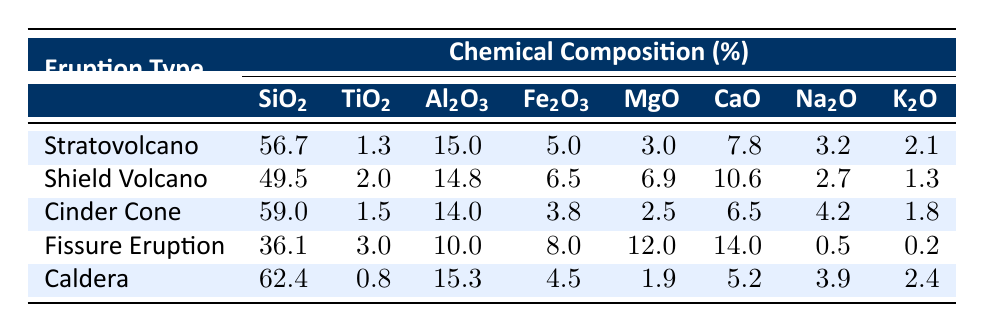What is the SiO2 percentage for the Stratovolcano sample? The table shows that the SiO2 percentage for the Stratovolcano sample (SV001) is listed directly in the corresponding cell under the SiO2 column for that eruption type.
Answer: 56.7 Which eruption type has the highest K2O content? By comparing the K2O values for each eruption type in the table, I can see that the Caldera eruption type (CA005) has the highest K2O content at 2.4.
Answer: Caldera What is the average Fe2O3 content across all eruption types? To find the average Fe2O3 content, I add the Fe2O3 values (5.0 + 6.5 + 3.8 + 8.0 + 4.5 = 27.8) and divide by the number of eruption types (5). The average is 27.8 / 5 = 5.56.
Answer: 5.56 Does the Cinder Cone eruption type have the lowest MgO content? I check the MgO values for all eruption types and find that Cinder Cone (CC003) has a MgO content of 2.5, which is higher than Fissure Eruption (FE004) at 12.0 and lower than both Stratovolcano and Shield Volcano, thus it's false.
Answer: No What is the difference in SiO2 content between the Stratovolcano and Caldera eruption types? The SiO2 content for the Stratovolcano is 56.7 and for the Caldera it is 62.4. To find the difference, I subtract the SiO2 of Stratovolcano from Caldera: 62.4 - 56.7 = 5.7.
Answer: 5.7 Which eruption type has the lowest Na2O content? By examining the Na2O content across the eruption types, I find that the Fissure Eruption sample (FE004) has the lowest Na2O, with a value of 0.5.
Answer: Fissure Eruption What is the total Al2O3 content for Shield Volcano and Caldera? I need to add the Al2O3 values from both Shield Volcano (14.8) and Caldera (15.3). Therefore, the total Al2O3 content is 14.8 + 15.3 = 30.1.
Answer: 30.1 Are the TiO2 levels higher in Cinder Cone than in Stratovolcano? I compare the TiO2 levels: Cinder Cone has 1.5 and Stratovolcano has 1.3. Since 1.5 is greater than 1.3, the statement is true.
Answer: Yes 